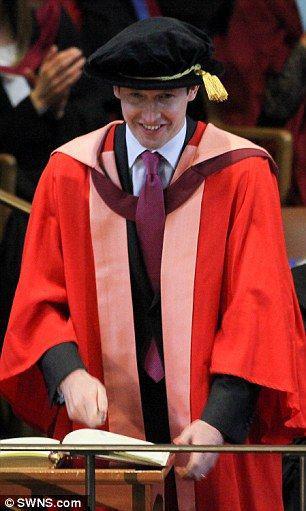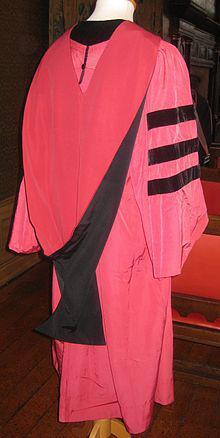The first image is the image on the left, the second image is the image on the right. Evaluate the accuracy of this statement regarding the images: "One of the graduates is standing at a podium.". Is it true? Answer yes or no. Yes. The first image is the image on the left, the second image is the image on the right. Considering the images on both sides, is "There is a man in the left image standing at a lectern." valid? Answer yes or no. Yes. 